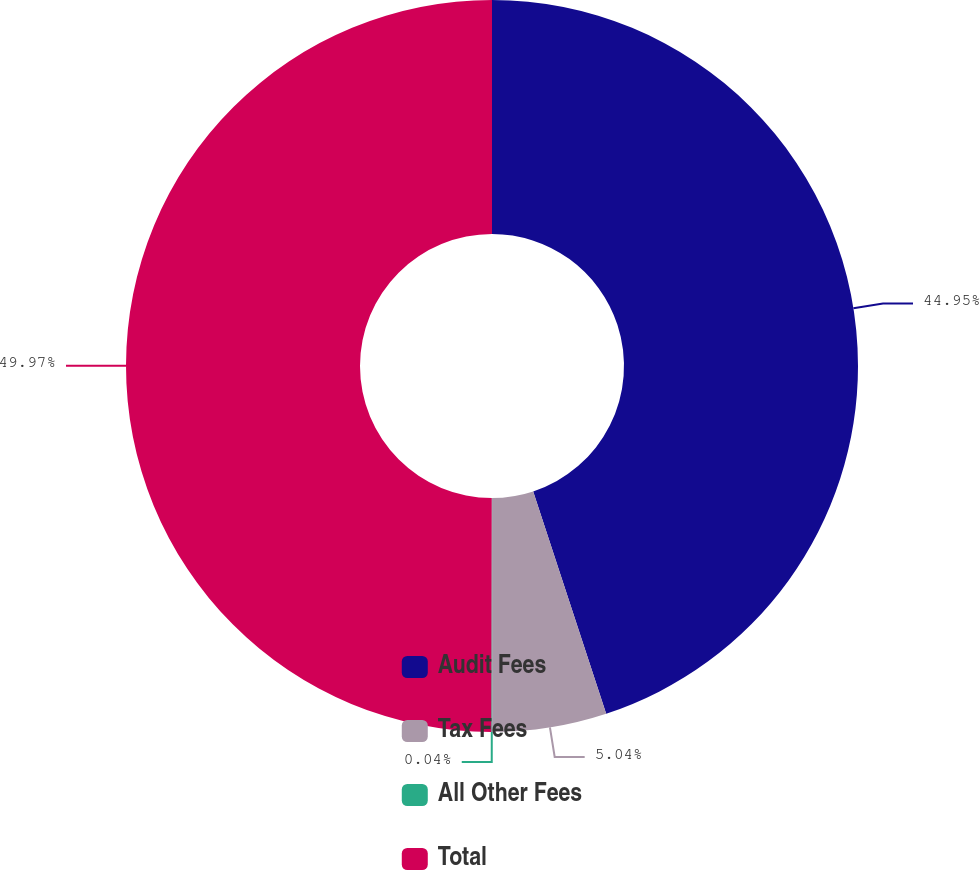<chart> <loc_0><loc_0><loc_500><loc_500><pie_chart><fcel>Audit Fees<fcel>Tax Fees<fcel>All Other Fees<fcel>Total<nl><fcel>44.95%<fcel>5.04%<fcel>0.04%<fcel>49.97%<nl></chart> 